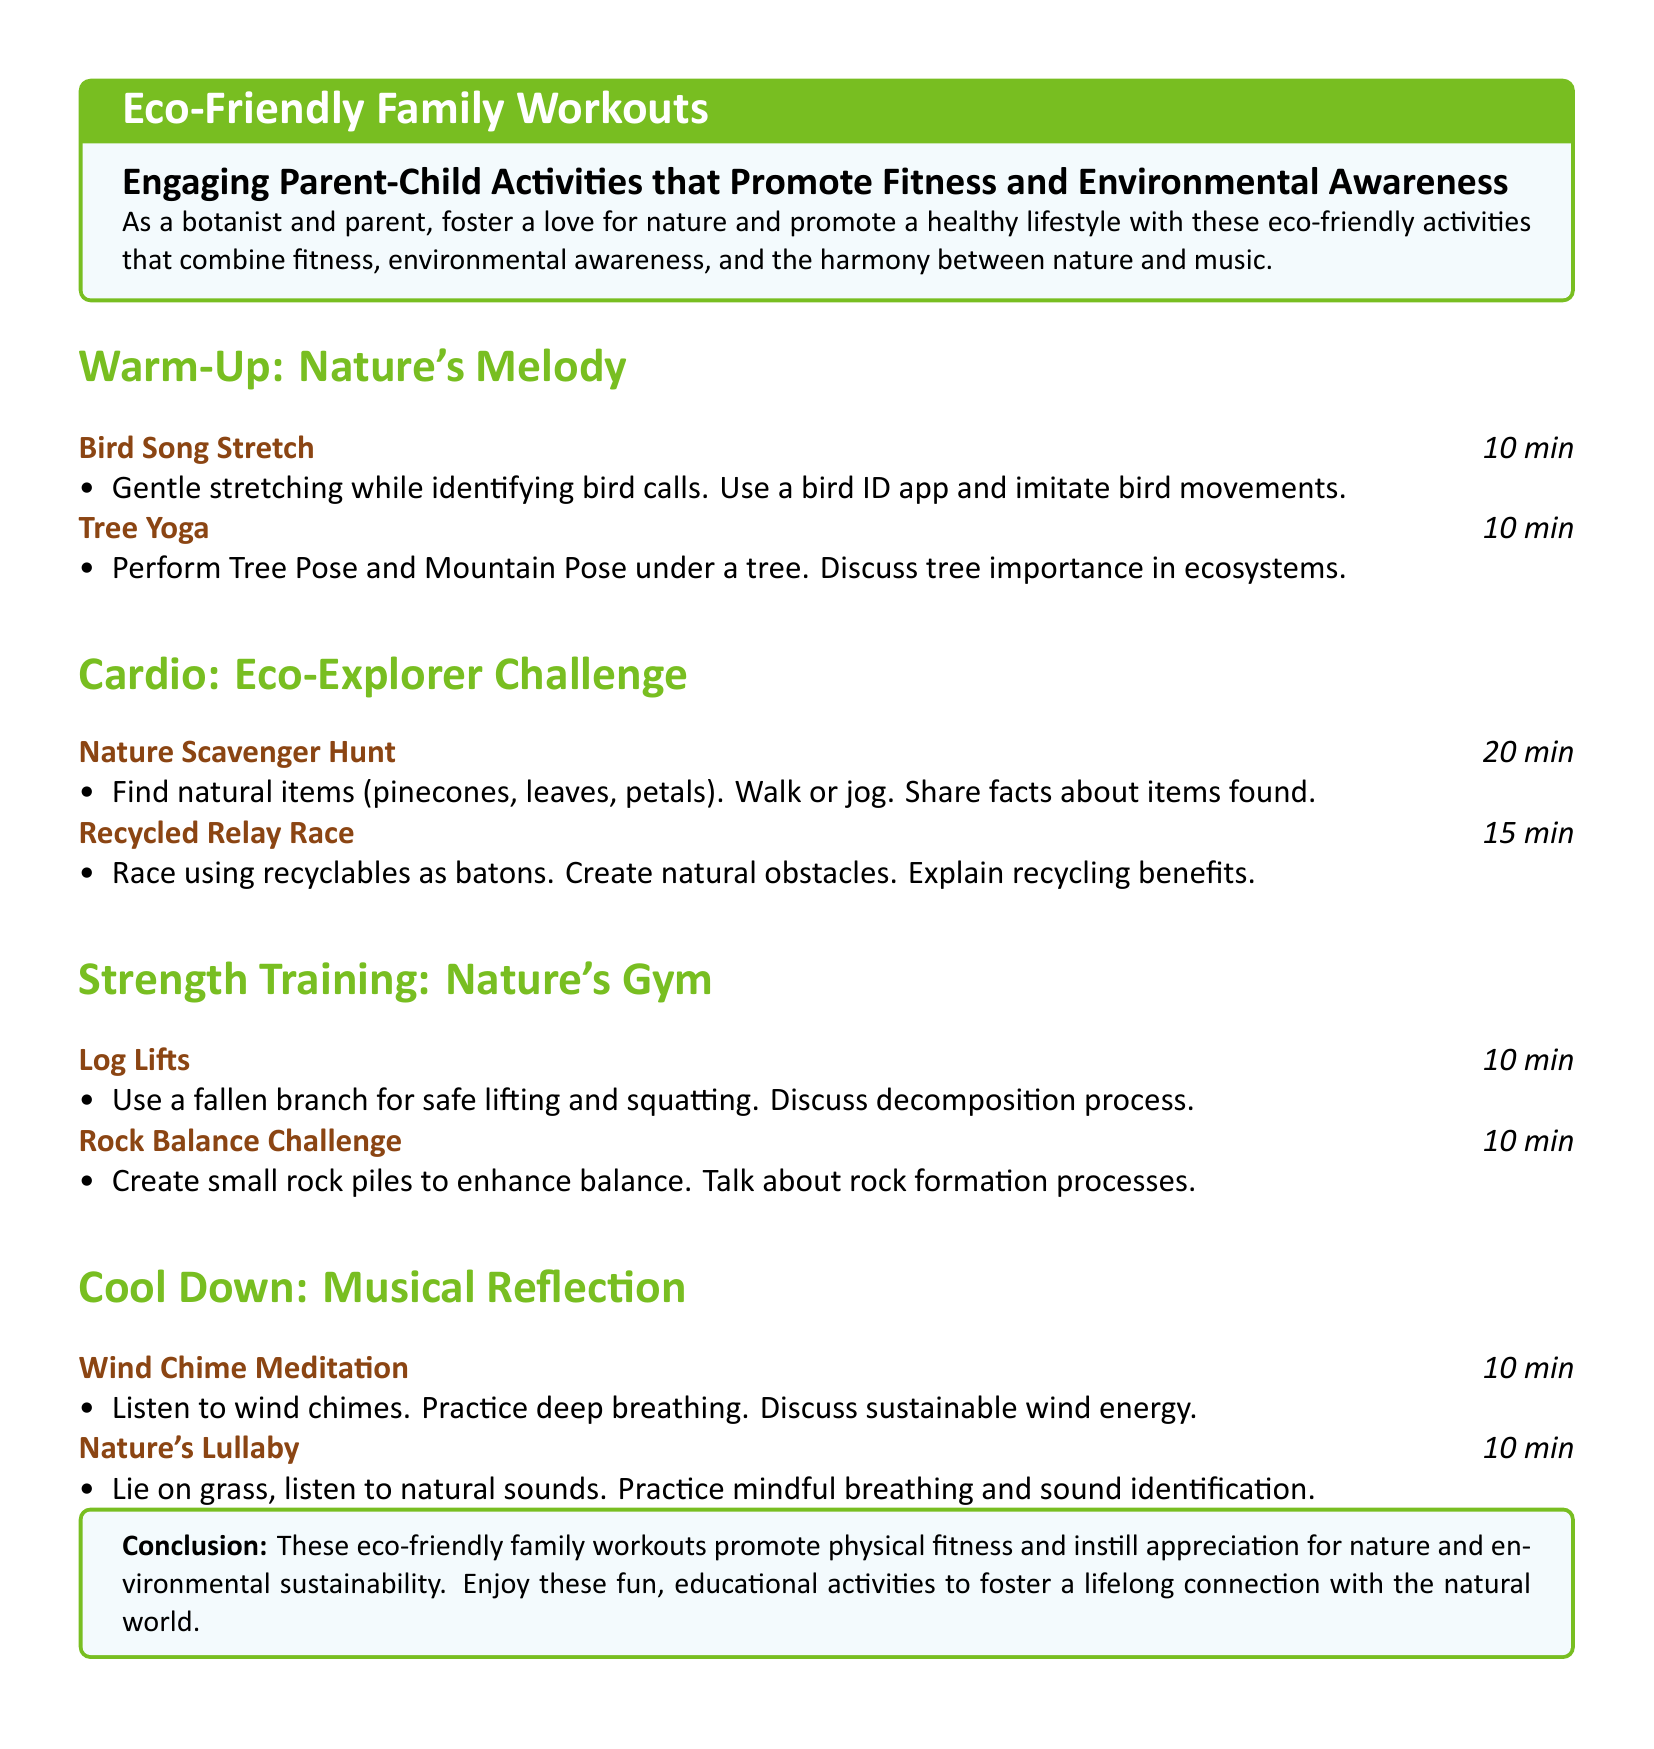what is the duration of the Bird Song Stretch? The duration of the Bird Song Stretch is mentioned in the workout as 10 minutes.
Answer: 10 min how many activities are included in the Cool Down section? The Cool Down section lists two activities: Wind Chime Meditation and Nature's Lullaby.
Answer: 2 what is the focus of the Nature Scavenger Hunt? The focus of the Nature Scavenger Hunt is to find natural items like pinecones and leaves while walking or jogging.
Answer: natural items which activity involves using a fallen branch for safe lifting and squatting? The activity that involves using a fallen branch is Log Lifts, as described under Nature's Gym.
Answer: Log Lifts what environmental topic is discussed during the Tree Yoga activity? The Tree Yoga activity discusses the importance of trees in ecosystems, linking fitness to environmental awareness.
Answer: tree importance how long is the Recycled Relay Race? The duration of the Recycled Relay Race is specified as 15 minutes.
Answer: 15 min what type of meditation is practiced in the Cool Down section? The type of meditation practiced is Wind Chime Meditation, which involves listening to wind chimes.
Answer: Wind Chime Meditation 